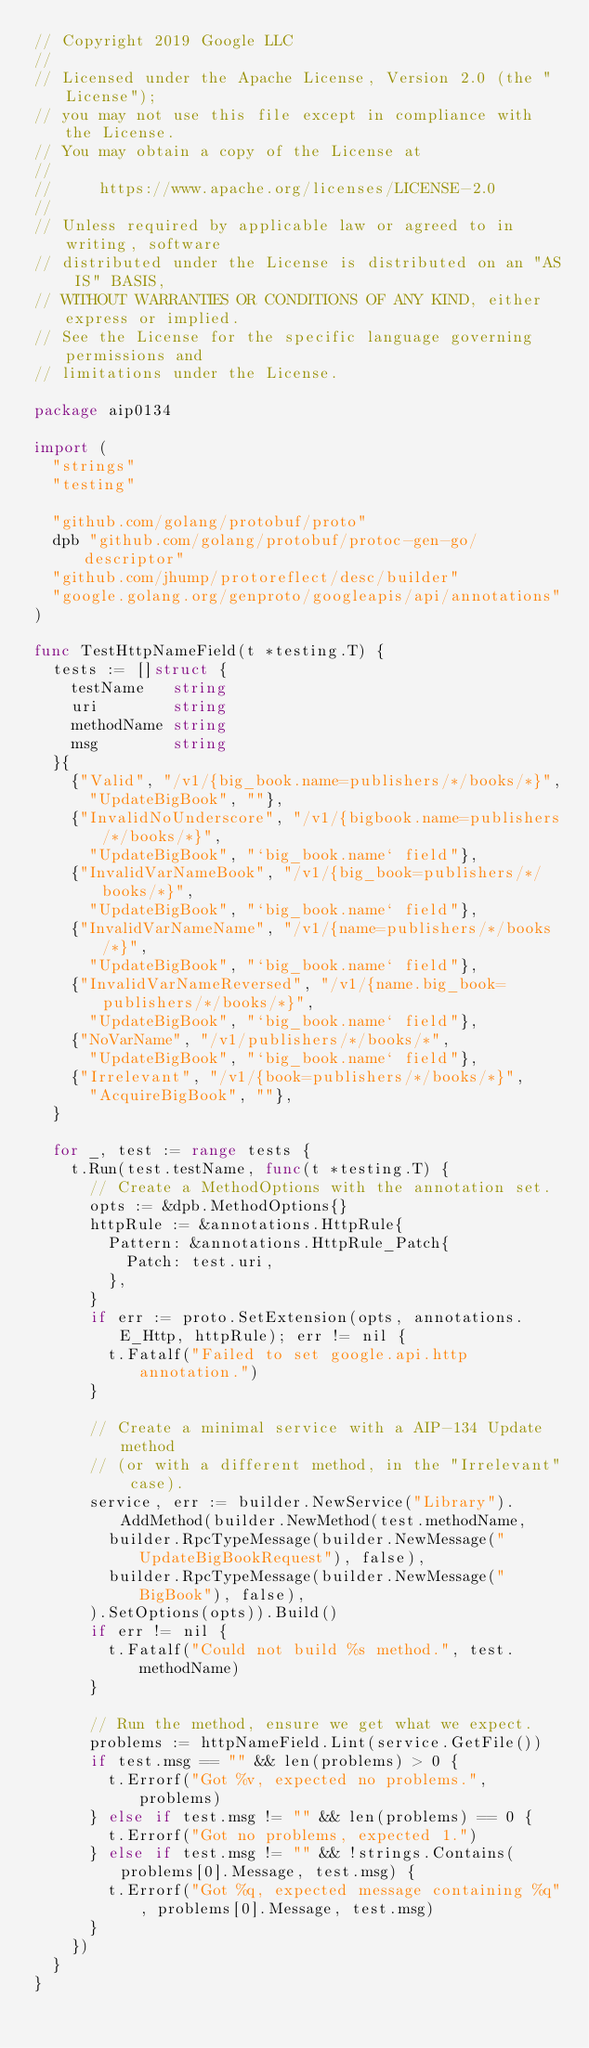Convert code to text. <code><loc_0><loc_0><loc_500><loc_500><_Go_>// Copyright 2019 Google LLC
//
// Licensed under the Apache License, Version 2.0 (the "License");
// you may not use this file except in compliance with the License.
// You may obtain a copy of the License at
//
//     https://www.apache.org/licenses/LICENSE-2.0
//
// Unless required by applicable law or agreed to in writing, software
// distributed under the License is distributed on an "AS IS" BASIS,
// WITHOUT WARRANTIES OR CONDITIONS OF ANY KIND, either express or implied.
// See the License for the specific language governing permissions and
// limitations under the License.

package aip0134

import (
	"strings"
	"testing"

	"github.com/golang/protobuf/proto"
	dpb "github.com/golang/protobuf/protoc-gen-go/descriptor"
	"github.com/jhump/protoreflect/desc/builder"
	"google.golang.org/genproto/googleapis/api/annotations"
)

func TestHttpNameField(t *testing.T) {
	tests := []struct {
		testName   string
		uri        string
		methodName string
		msg        string
	}{
		{"Valid", "/v1/{big_book.name=publishers/*/books/*}",
			"UpdateBigBook", ""},
		{"InvalidNoUnderscore", "/v1/{bigbook.name=publishers/*/books/*}",
			"UpdateBigBook", "`big_book.name` field"},
		{"InvalidVarNameBook", "/v1/{big_book=publishers/*/books/*}",
			"UpdateBigBook", "`big_book.name` field"},
		{"InvalidVarNameName", "/v1/{name=publishers/*/books/*}",
			"UpdateBigBook", "`big_book.name` field"},
		{"InvalidVarNameReversed", "/v1/{name.big_book=publishers/*/books/*}",
			"UpdateBigBook", "`big_book.name` field"},
		{"NoVarName", "/v1/publishers/*/books/*",
			"UpdateBigBook", "`big_book.name` field"},
		{"Irrelevant", "/v1/{book=publishers/*/books/*}",
			"AcquireBigBook", ""},
	}

	for _, test := range tests {
		t.Run(test.testName, func(t *testing.T) {
			// Create a MethodOptions with the annotation set.
			opts := &dpb.MethodOptions{}
			httpRule := &annotations.HttpRule{
				Pattern: &annotations.HttpRule_Patch{
					Patch: test.uri,
				},
			}
			if err := proto.SetExtension(opts, annotations.E_Http, httpRule); err != nil {
				t.Fatalf("Failed to set google.api.http annotation.")
			}

			// Create a minimal service with a AIP-134 Update method
			// (or with a different method, in the "Irrelevant" case).
			service, err := builder.NewService("Library").AddMethod(builder.NewMethod(test.methodName,
				builder.RpcTypeMessage(builder.NewMessage("UpdateBigBookRequest"), false),
				builder.RpcTypeMessage(builder.NewMessage("BigBook"), false),
			).SetOptions(opts)).Build()
			if err != nil {
				t.Fatalf("Could not build %s method.", test.methodName)
			}

			// Run the method, ensure we get what we expect.
			problems := httpNameField.Lint(service.GetFile())
			if test.msg == "" && len(problems) > 0 {
				t.Errorf("Got %v, expected no problems.", problems)
			} else if test.msg != "" && len(problems) == 0 {
				t.Errorf("Got no problems, expected 1.")
			} else if test.msg != "" && !strings.Contains(problems[0].Message, test.msg) {
				t.Errorf("Got %q, expected message containing %q", problems[0].Message, test.msg)
			}
		})
	}
}
</code> 